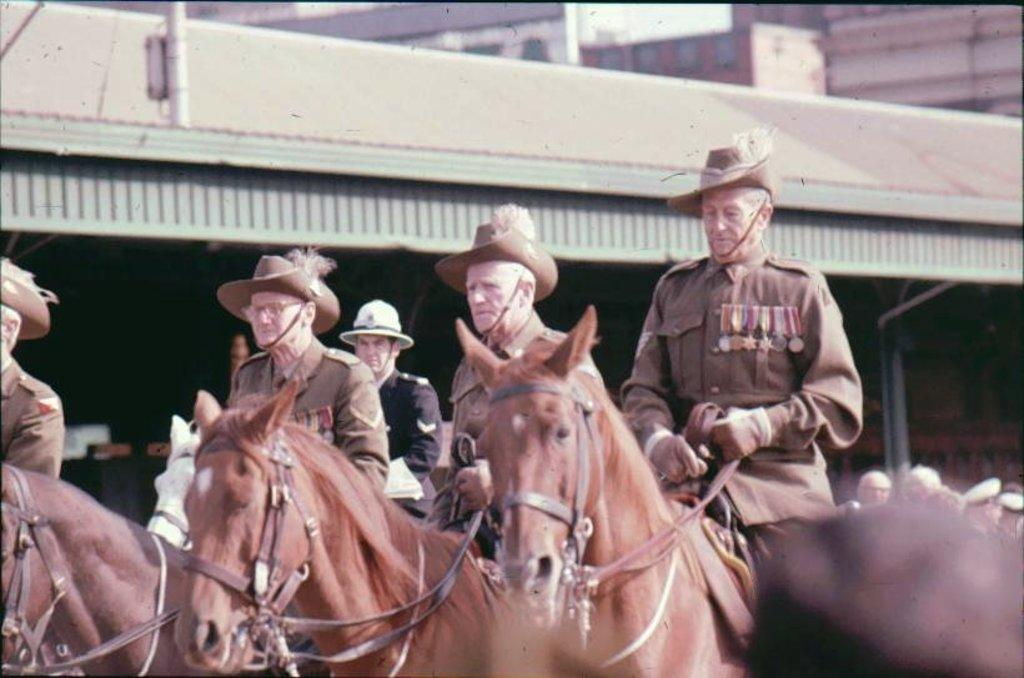What is happening in the image involving a horse? There are people riding a horse in the image. What can be seen in the distance behind the horse and riders? There are buildings in the background of the image. Can you see a cat in the image? There is no mention of a cat in the image, so it cannot be confirmed or denied. 